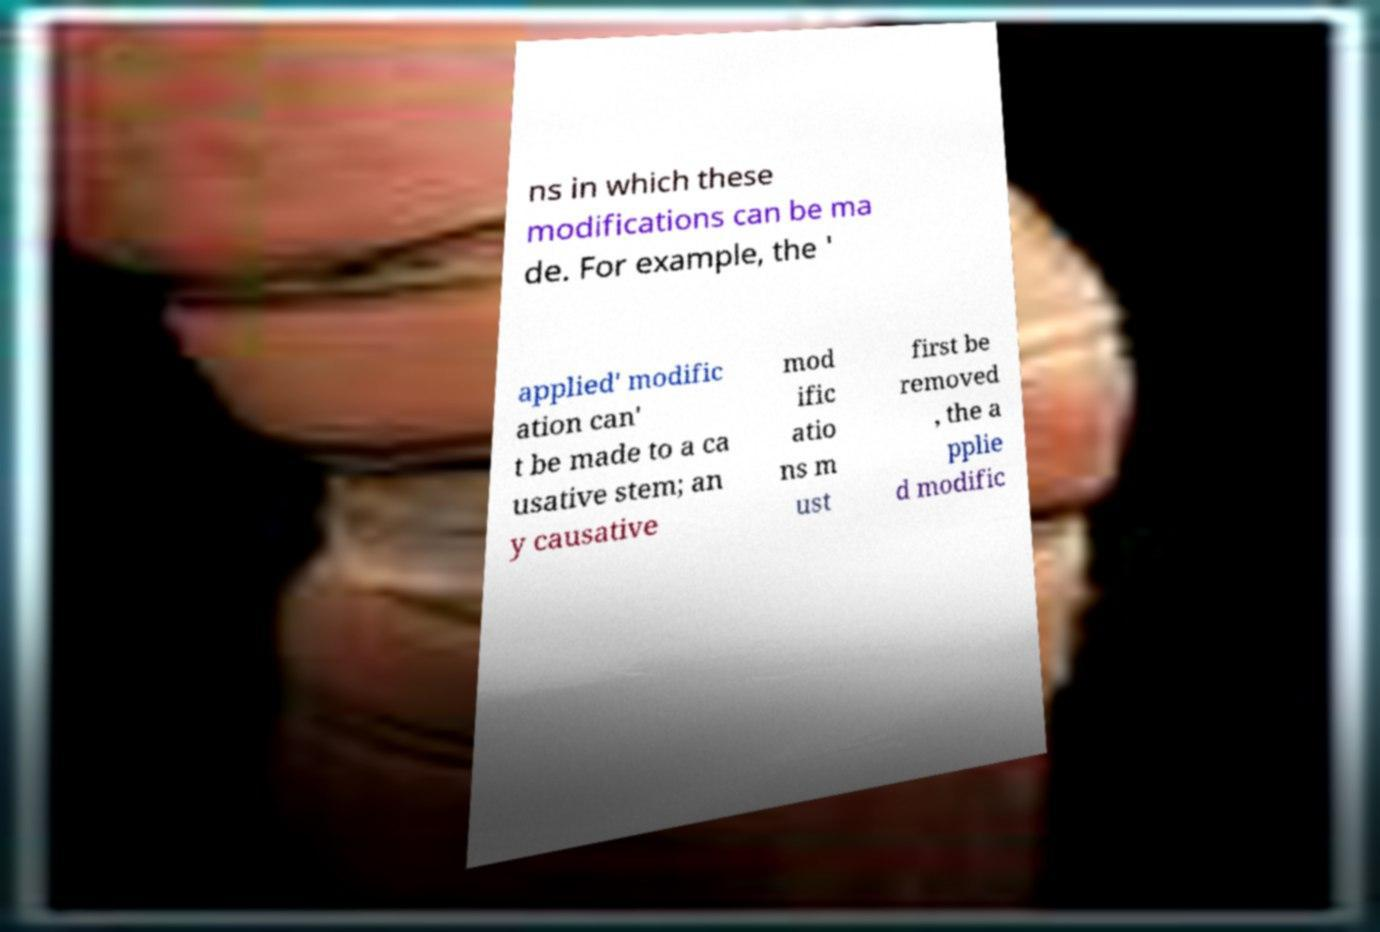Please read and relay the text visible in this image. What does it say? ns in which these modifications can be ma de. For example, the ' applied' modific ation can' t be made to a ca usative stem; an y causative mod ific atio ns m ust first be removed , the a pplie d modific 